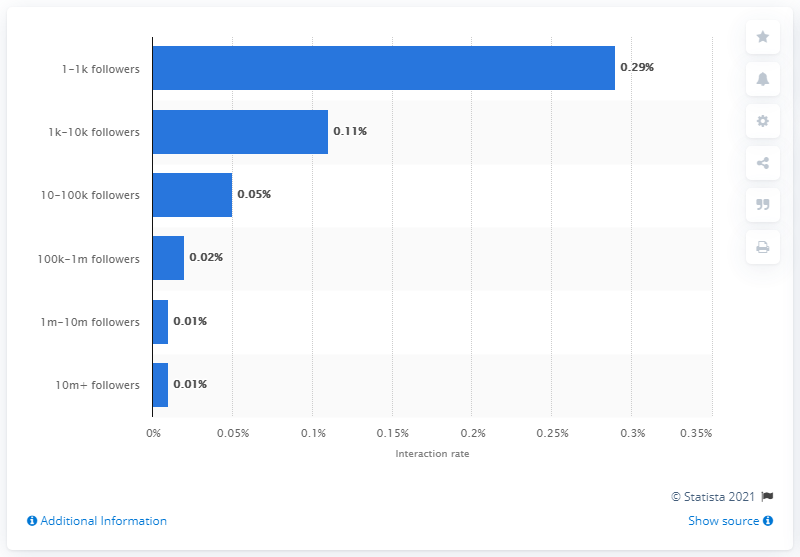Highlight a few significant elements in this photo. The interaction rate of brand profiles with 10 to 100 thousand followers was 0.05. In September 2016, the average number of followers on a brand profile was approximately 0.05. 